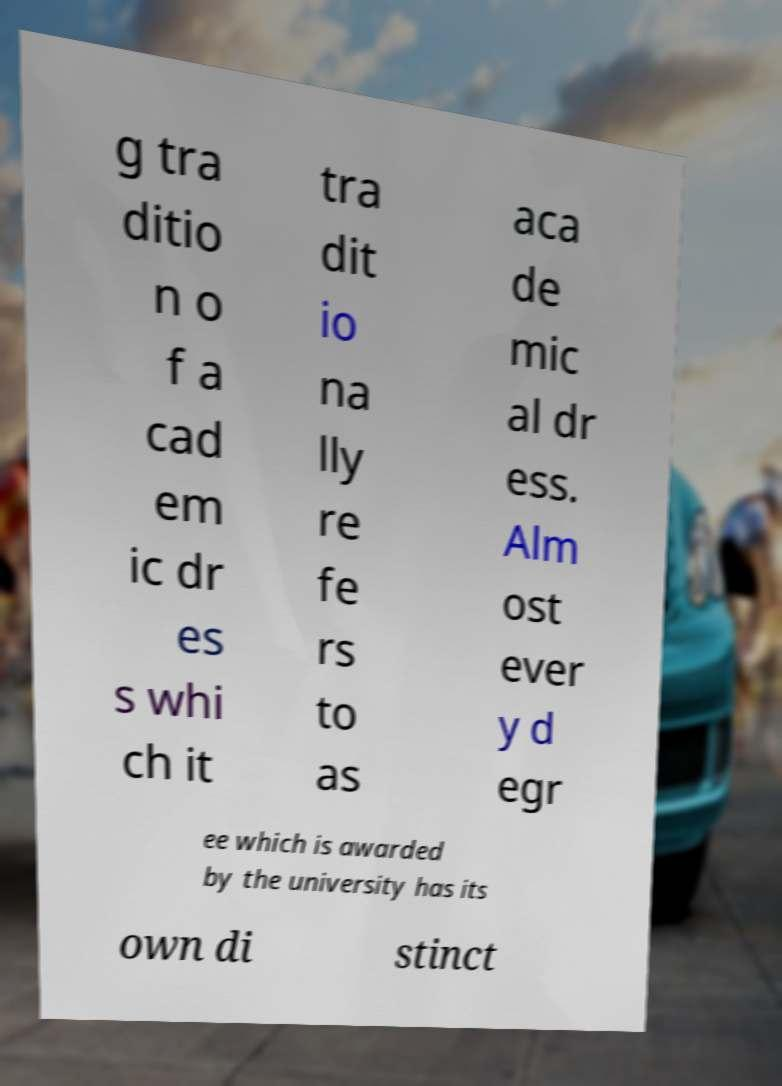Could you assist in decoding the text presented in this image and type it out clearly? g tra ditio n o f a cad em ic dr es s whi ch it tra dit io na lly re fe rs to as aca de mic al dr ess. Alm ost ever y d egr ee which is awarded by the university has its own di stinct 